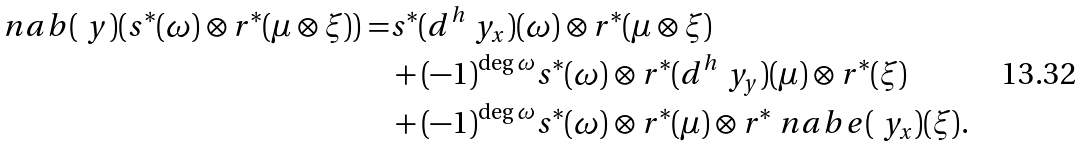<formula> <loc_0><loc_0><loc_500><loc_500>\ n a b ( \ y ) ( s ^ { * } ( \omega ) \otimes r ^ { * } ( \mu \otimes \xi ) ) = & s ^ { * } ( d ^ { h } \ y _ { x } ) ( \omega ) \otimes r ^ { * } ( \mu \otimes \xi ) \\ & + ( - 1 ) ^ { \deg \omega } s ^ { * } ( \omega ) \otimes r ^ { * } ( d ^ { h } \ y _ { y } ) ( \mu ) \otimes r ^ { * } ( \xi ) \\ & + ( - 1 ) ^ { \deg \omega } s ^ { * } ( \omega ) \otimes r ^ { * } ( \mu ) \otimes r ^ { * } \ n a b e ( \ y _ { x } ) ( \xi ) .</formula> 